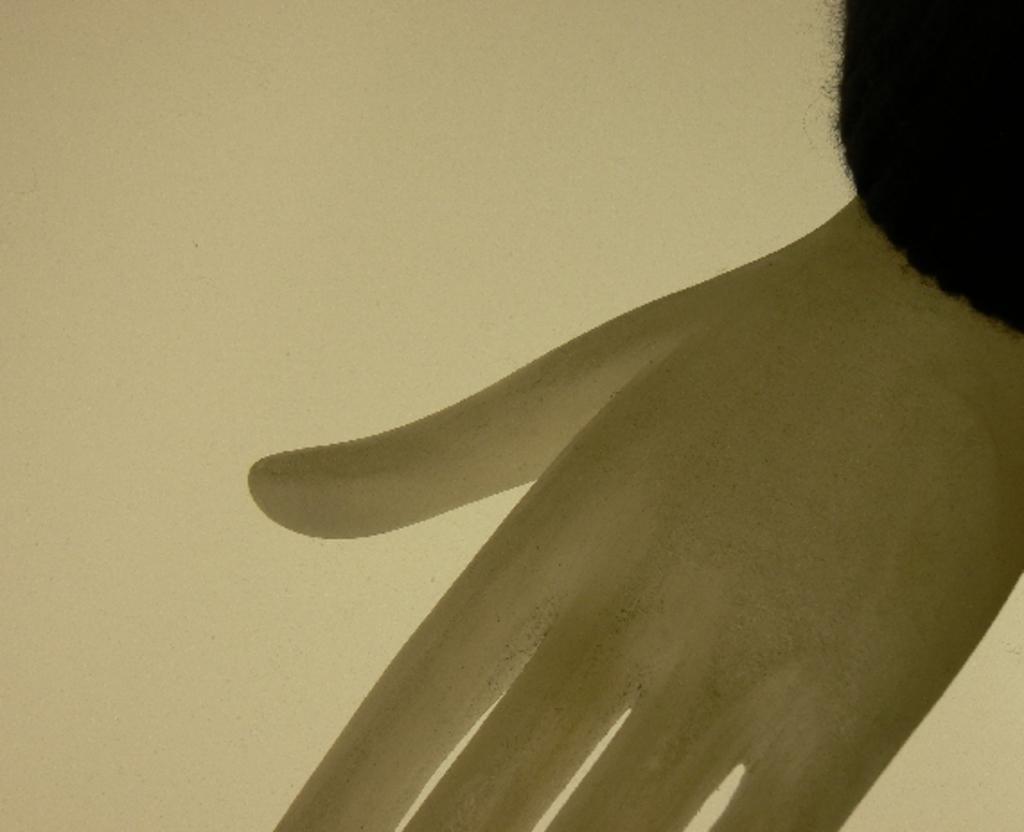Can you describe this image briefly? In the center of the image we can see hand of a mannequin. In the background there is wall. 